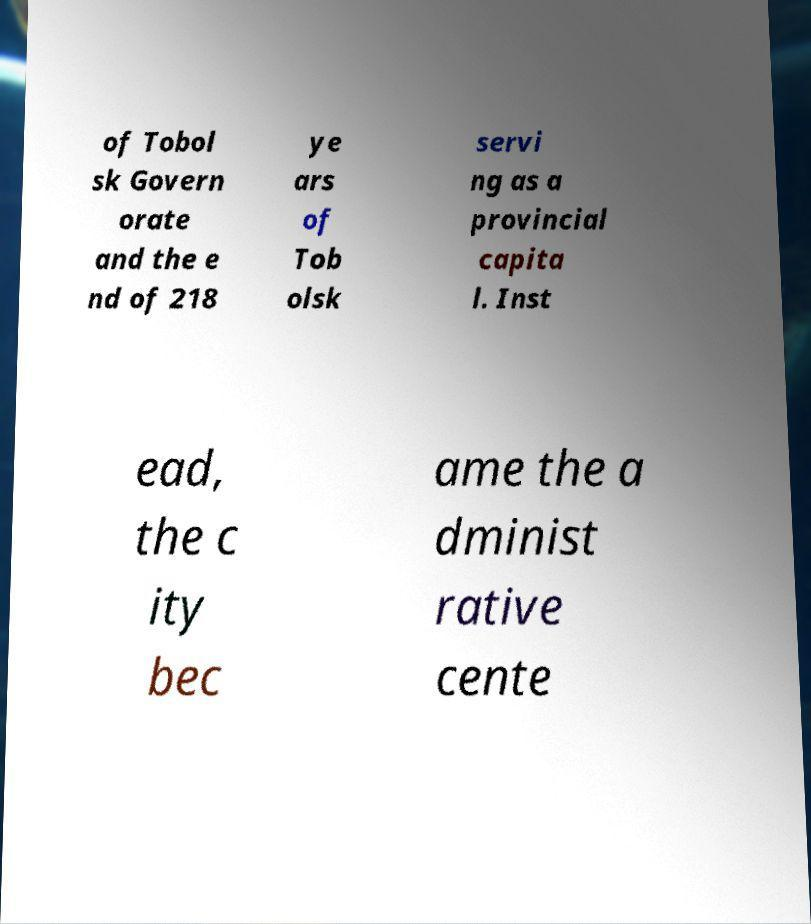What messages or text are displayed in this image? I need them in a readable, typed format. of Tobol sk Govern orate and the e nd of 218 ye ars of Tob olsk servi ng as a provincial capita l. Inst ead, the c ity bec ame the a dminist rative cente 